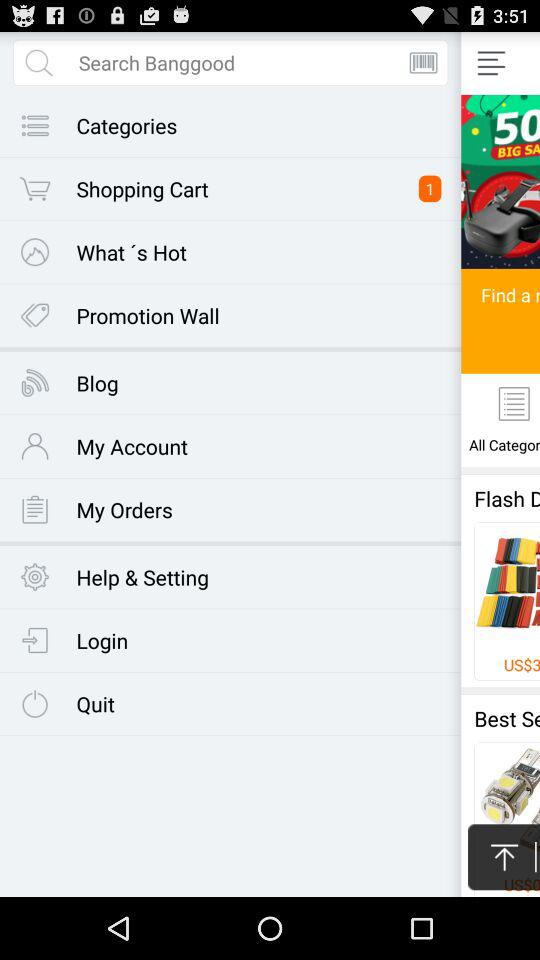How many people gave reviews for the product? There are 6 people who gave reviews for the product. 